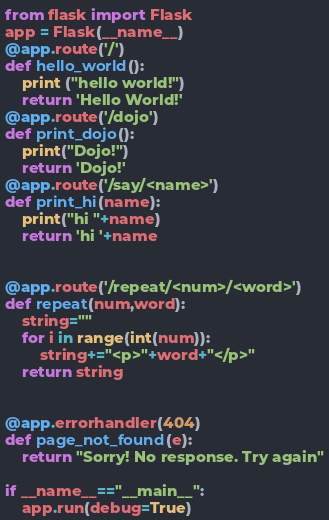Convert code to text. <code><loc_0><loc_0><loc_500><loc_500><_Python_>from flask import Flask 
app = Flask(__name__)
@app.route('/')
def hello_world():
    print ("hello world!")
    return 'Hello World!'
@app.route('/dojo')
def print_dojo():
    print("Dojo!")
    return 'Dojo!'
@app.route('/say/<name>')
def print_hi(name):
    print("hi "+name)
    return 'hi '+name


@app.route('/repeat/<num>/<word>')
def repeat(num,word):
    string=""
    for i in range(int(num)):
        string+="<p>"+word+"</p>"
    return string


@app.errorhandler(404)
def page_not_found(e):
    return "Sorry! No response. Try again"

if __name__=="__main__":
    app.run(debug=True)</code> 